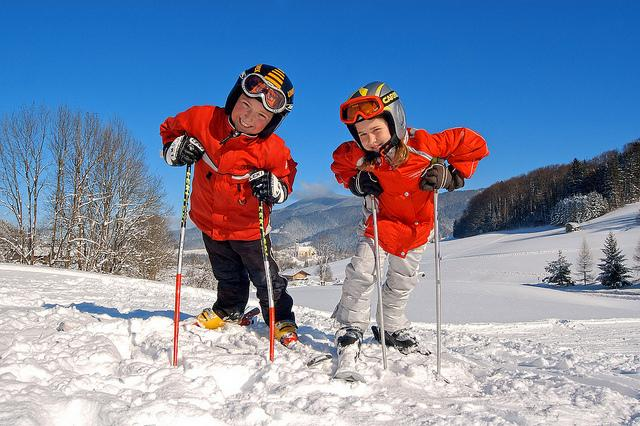Where is most of the kids weight? poles 